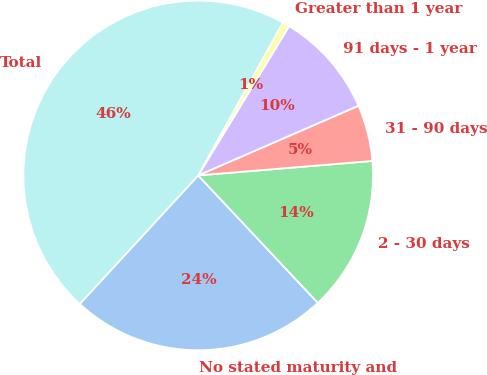<chart> <loc_0><loc_0><loc_500><loc_500><pie_chart><fcel>No stated maturity and<fcel>2 - 30 days<fcel>31 - 90 days<fcel>91 days - 1 year<fcel>Greater than 1 year<fcel>Total<nl><fcel>23.85%<fcel>14.32%<fcel>5.21%<fcel>9.77%<fcel>0.66%<fcel>46.2%<nl></chart> 